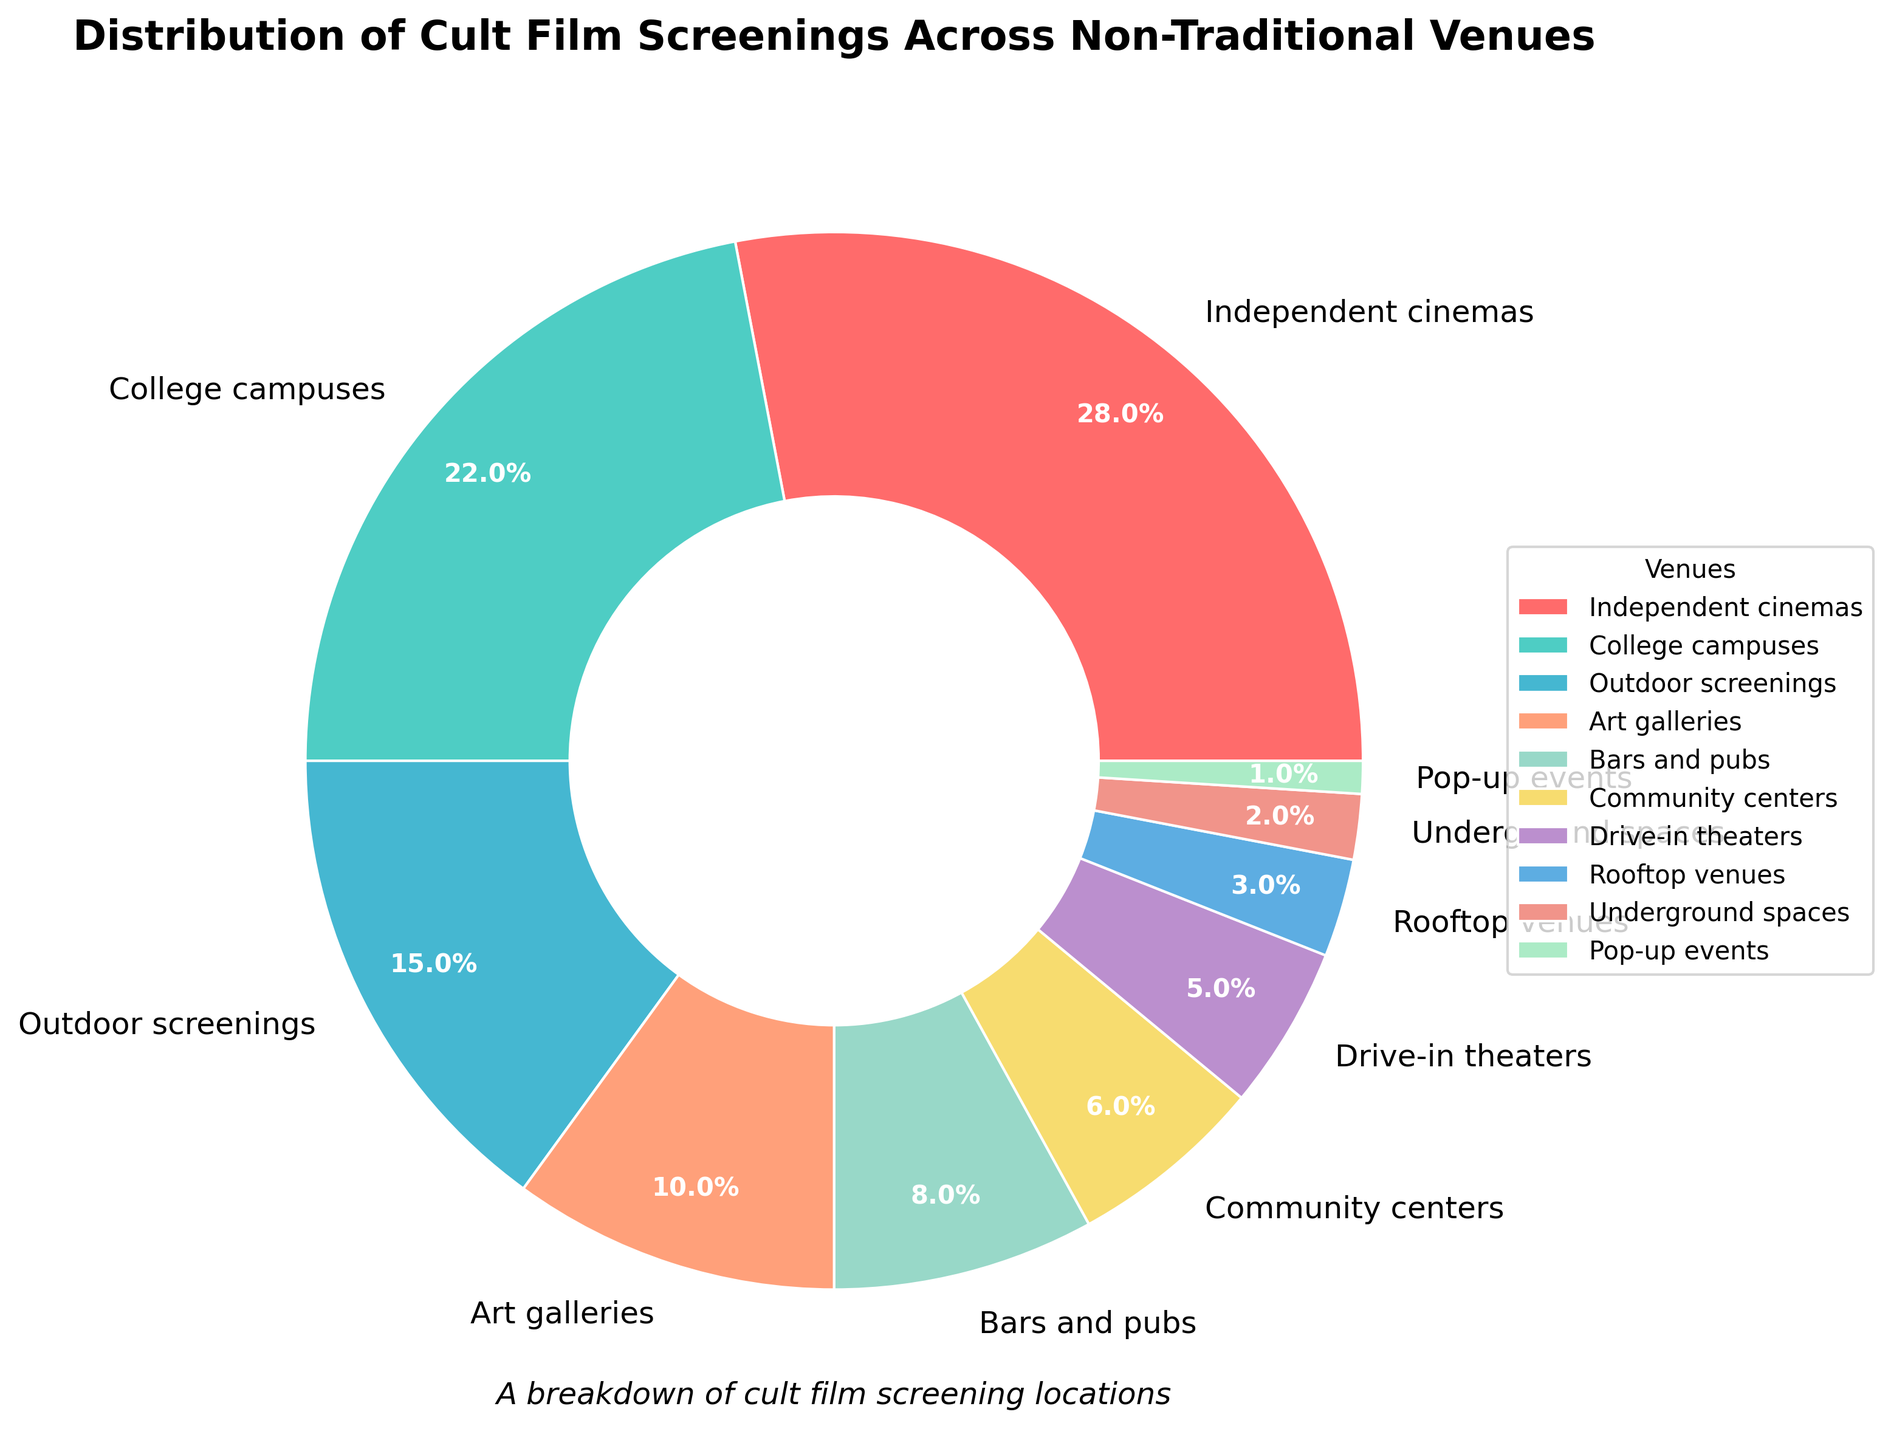What's the most popular venue for cult film screenings? Look for the venue with the largest percentage slice in the pie chart. Independent cinemas have the highest percentage at 28%.
Answer: Independent cinemas Which venue has a lower percentage, bars and pubs or community centers? Compare the percentages of the two venues. Bars and pubs are at 8% and community centers are at 6%. Bars and pubs are higher.
Answer: Community centers What's the combined percentage of screenings at outdoor screenings and rooftop venues? Sum the percentages of outdoor screenings (15%) and rooftop venues (3%). 15% + 3% = 18%.
Answer: 18% How many venues have a percentage of 5% or less? Count the wedges in the pie chart with percentages less than or equal to 5%. Drive-in theaters, rooftop venues, underground spaces, and pop-up events make a total of 4 venues.
Answer: 4 Which venues have a combined percentage equal to that of independent cinemas? Identify venues that together sum up to 28%. Outdoor screenings (15%) + bars and pubs (8%) + community centers (6%) = 29%, which is slightly over. However, college campuses (22%) + bars and pubs (6%), fall short at 28%. Therefore, college campuses (22%) + outdoor screenings (15%) - rooftop venues (3%) = 28%.
Answer: College campuses and outdoor screenings minus rooftop venues Are there more screenings at art galleries or pop-up events? Compare the two percentages. Art galleries have 10% while pop-up events have 1%.
Answer: Art galleries What's the visual cue used to distinguish venues? Look for the graphical element that visually separates different wedges. The chart uses different colors for each venue.
Answer: Different colors Which venue, college campuses or outdoor screenings, holds more screenings? Compare their respective percentages. College campuses have 22% and outdoor screenings have 15%.
Answer: College campuses Arrange the venues in descending order based on their percentages. Convert the pie chart's visual information into a sorted list from the highest to the lowest percentage: Independent cinemas (28%), college campuses (22%), outdoor screenings (15%), art galleries (10%), bars and pubs (8%), community centers (6%), drive-in theaters (5%), rooftop venues (3%), underground spaces (2%), pop-up events (1%).
Answer: Independent cinemas, college campuses, outdoor screenings, art galleries, bars and pubs, community centers, drive-in theaters, rooftop venues, underground spaces, pop-up events 